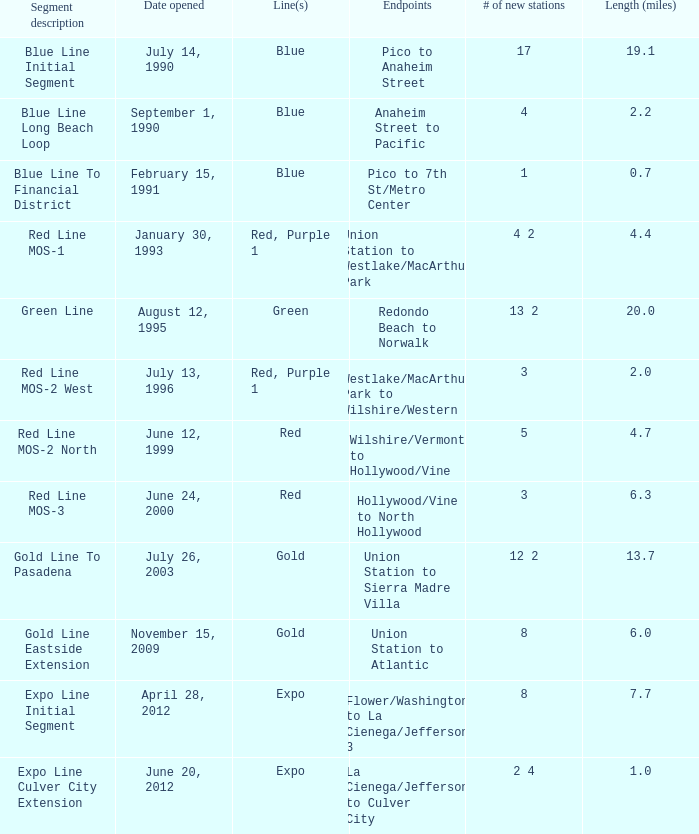What is the length  (miles) when pico to 7th st/metro center are the endpoints? 0.7. 